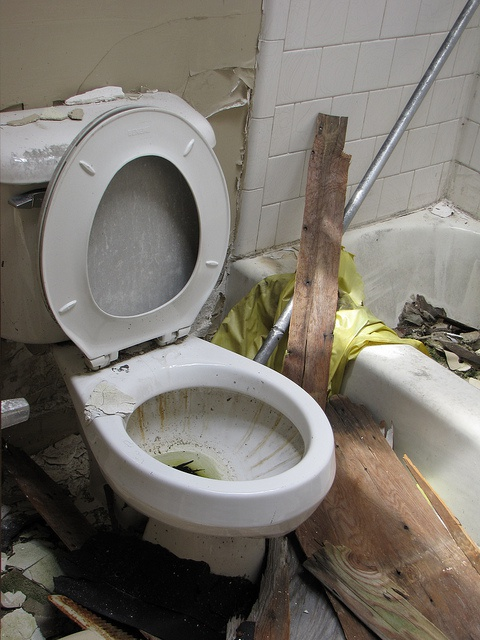Describe the objects in this image and their specific colors. I can see a toilet in gray, darkgray, lightgray, and black tones in this image. 